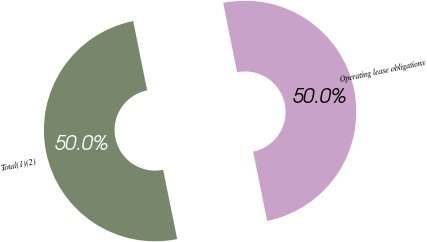<chart> <loc_0><loc_0><loc_500><loc_500><pie_chart><fcel>Operating lease obligations<fcel>Total(1)(2)<nl><fcel>49.97%<fcel>50.03%<nl></chart> 